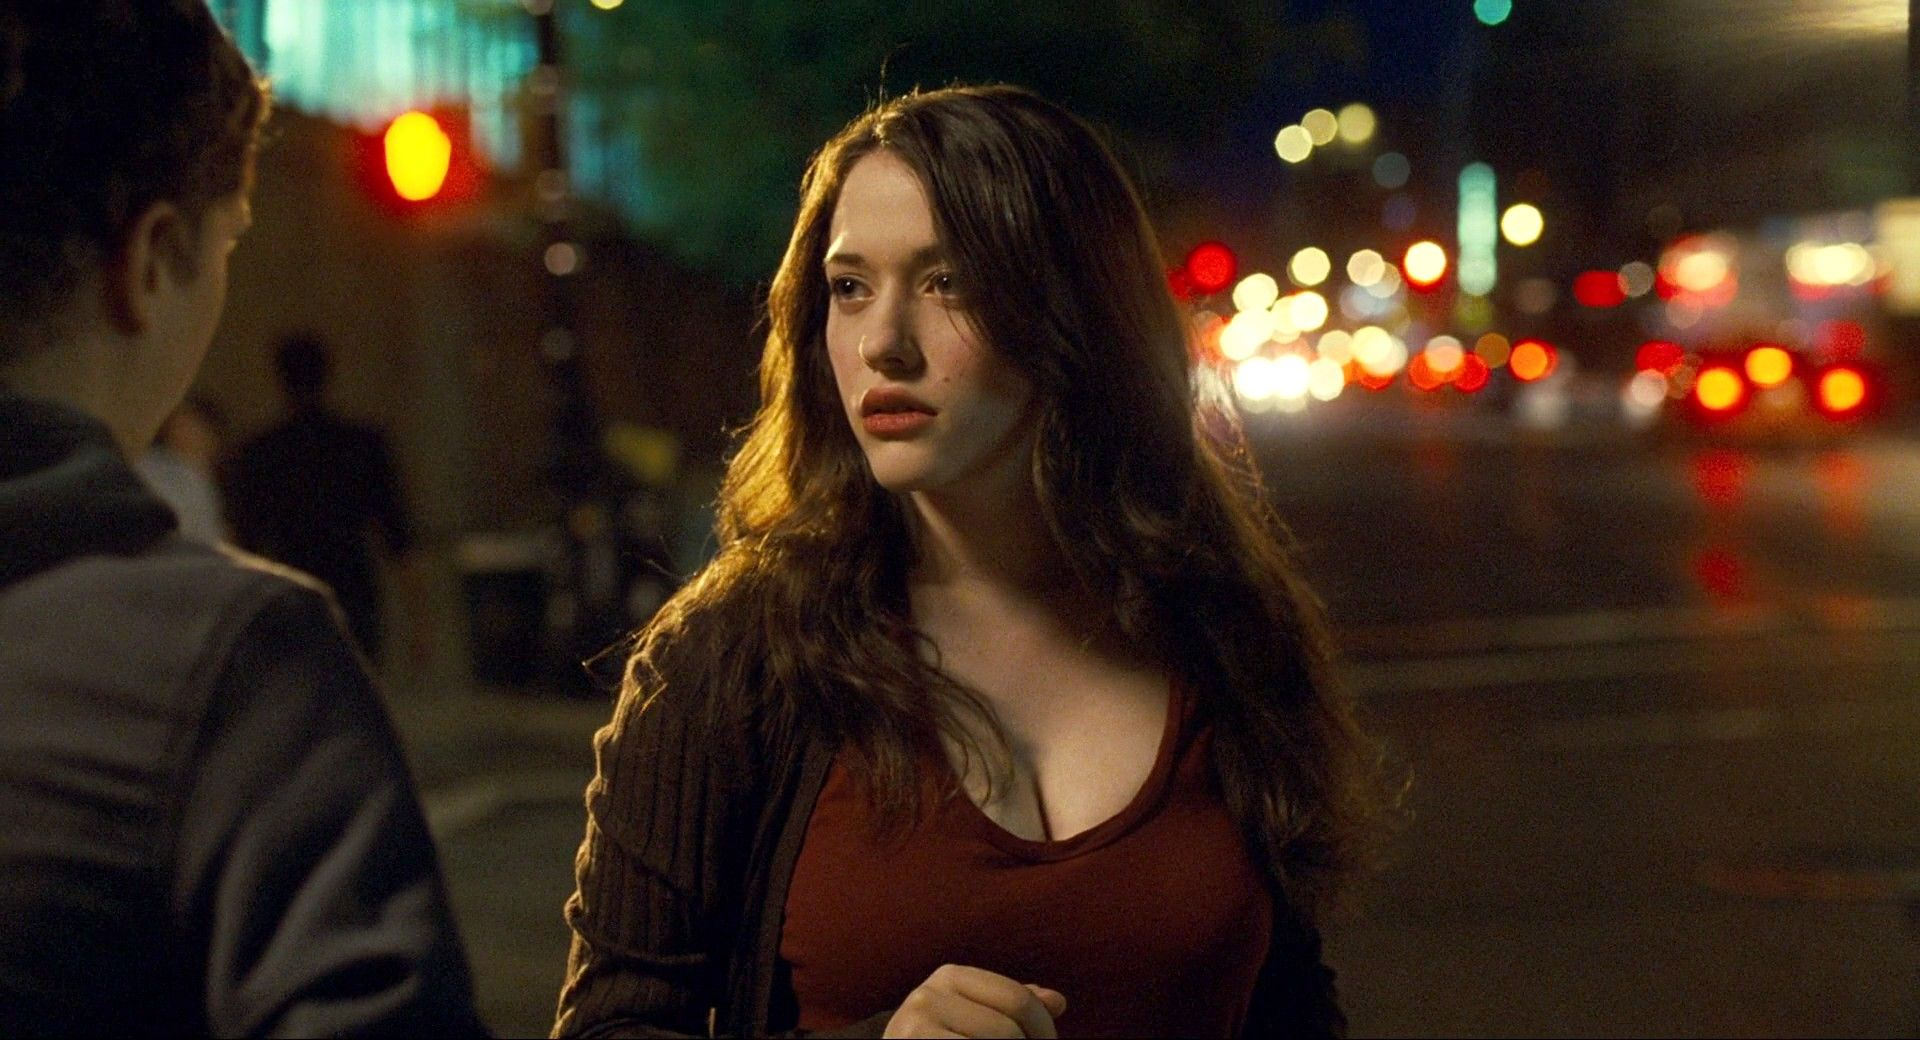What do you think is happening in this scene? The scene seems to depict a young woman experiencing a poignant moment on a lively city street at night. The blurred lights and passing cars suggest a bustling environment, while her introspective expression hints at a significant personal contemplation or anticipation. Perhaps she is waiting for someone important or reflecting on an event that recently occurred. 